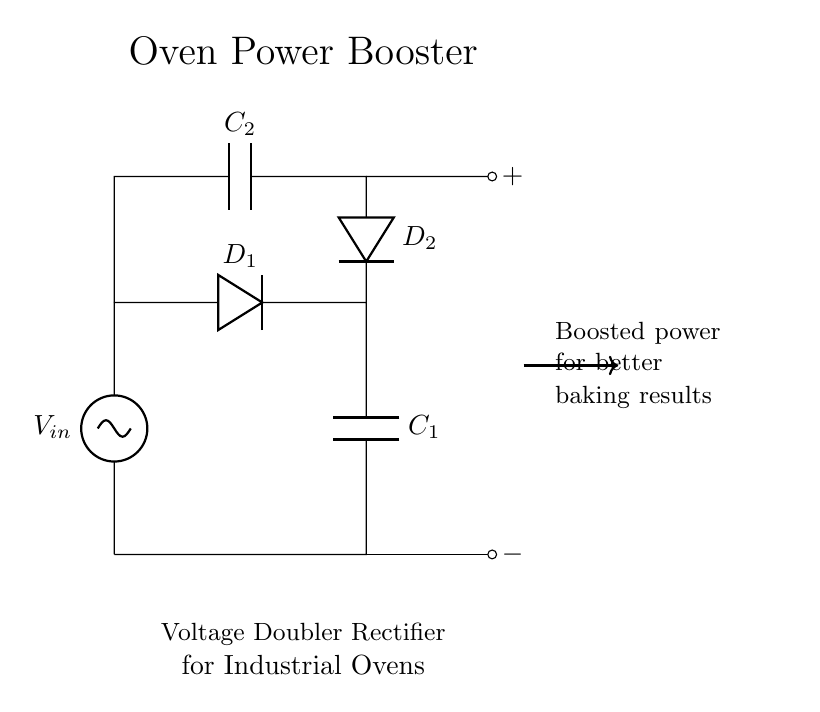What is the role of the capacitors in this circuit? The capacitors, C1 and C2, serve to store charge, which helps in boosting the voltage output of the rectifier. They accumulate energy during the charging phase and release it to provide a higher voltage during the discharge phase.
Answer: Store charge What do the diodes in the circuit do? The diodes, D1 and D2, allow current to flow in one direction only, ensuring that the capacitors charge correctly and do not discharge back into the circuit. This rectification is essential for converting alternating current input into the desired direct current output.
Answer: Rectify current What is the significance of the term "voltage doubler"? The term "voltage doubler" means that this circuit design effectively doubles the input voltage across the output, allowing for higher voltage across the load than what was fed into the circuit. This is particularly useful in applications requiring higher voltage, such as in industrial ovens.
Answer: Doubles voltage How many capacitors are present in the circuit? There are two capacitors, C1 and C2, which work together to provide the voltage doubling effect in this rectifier circuit. Each capacitor plays a role in the timing and control of voltage boosting.
Answer: Two In which direction does the current flow through the diodes? The current flows through D1 from the input to C1 and then through D2 to C2, demonstrating how the diodes direct current towards the capacitors for charging and prevent reverse flow. This directional flow is crucial for the operation of the rectifier.
Answer: Forward What is the output voltage relative to the input voltage? The output voltage will be approximately double the input voltage due to the function of the voltage doubler design, which allows the capacitors to charge and boost the voltage output.
Answer: Approximately double 